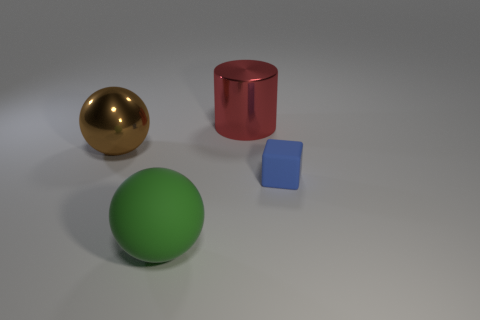Add 4 red matte objects. How many objects exist? 8 Subtract all blocks. How many objects are left? 3 Add 4 large spheres. How many large spheres exist? 6 Subtract 0 purple blocks. How many objects are left? 4 Subtract all big brown shiny balls. Subtract all brown objects. How many objects are left? 2 Add 4 big green rubber balls. How many big green rubber balls are left? 5 